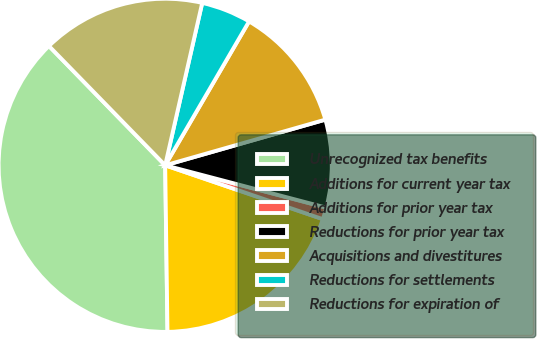Convert chart. <chart><loc_0><loc_0><loc_500><loc_500><pie_chart><fcel>Unrecognized tax benefits<fcel>Additions for current year tax<fcel>Additions for prior year tax<fcel>Reductions for prior year tax<fcel>Acquisitions and divestitures<fcel>Reductions for settlements<fcel>Reductions for expiration of<nl><fcel>37.93%<fcel>19.54%<fcel>1.15%<fcel>8.51%<fcel>12.18%<fcel>4.83%<fcel>15.86%<nl></chart> 